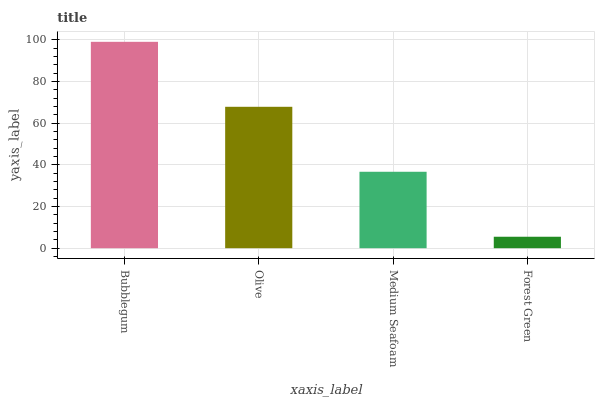Is Forest Green the minimum?
Answer yes or no. Yes. Is Bubblegum the maximum?
Answer yes or no. Yes. Is Olive the minimum?
Answer yes or no. No. Is Olive the maximum?
Answer yes or no. No. Is Bubblegum greater than Olive?
Answer yes or no. Yes. Is Olive less than Bubblegum?
Answer yes or no. Yes. Is Olive greater than Bubblegum?
Answer yes or no. No. Is Bubblegum less than Olive?
Answer yes or no. No. Is Olive the high median?
Answer yes or no. Yes. Is Medium Seafoam the low median?
Answer yes or no. Yes. Is Forest Green the high median?
Answer yes or no. No. Is Bubblegum the low median?
Answer yes or no. No. 